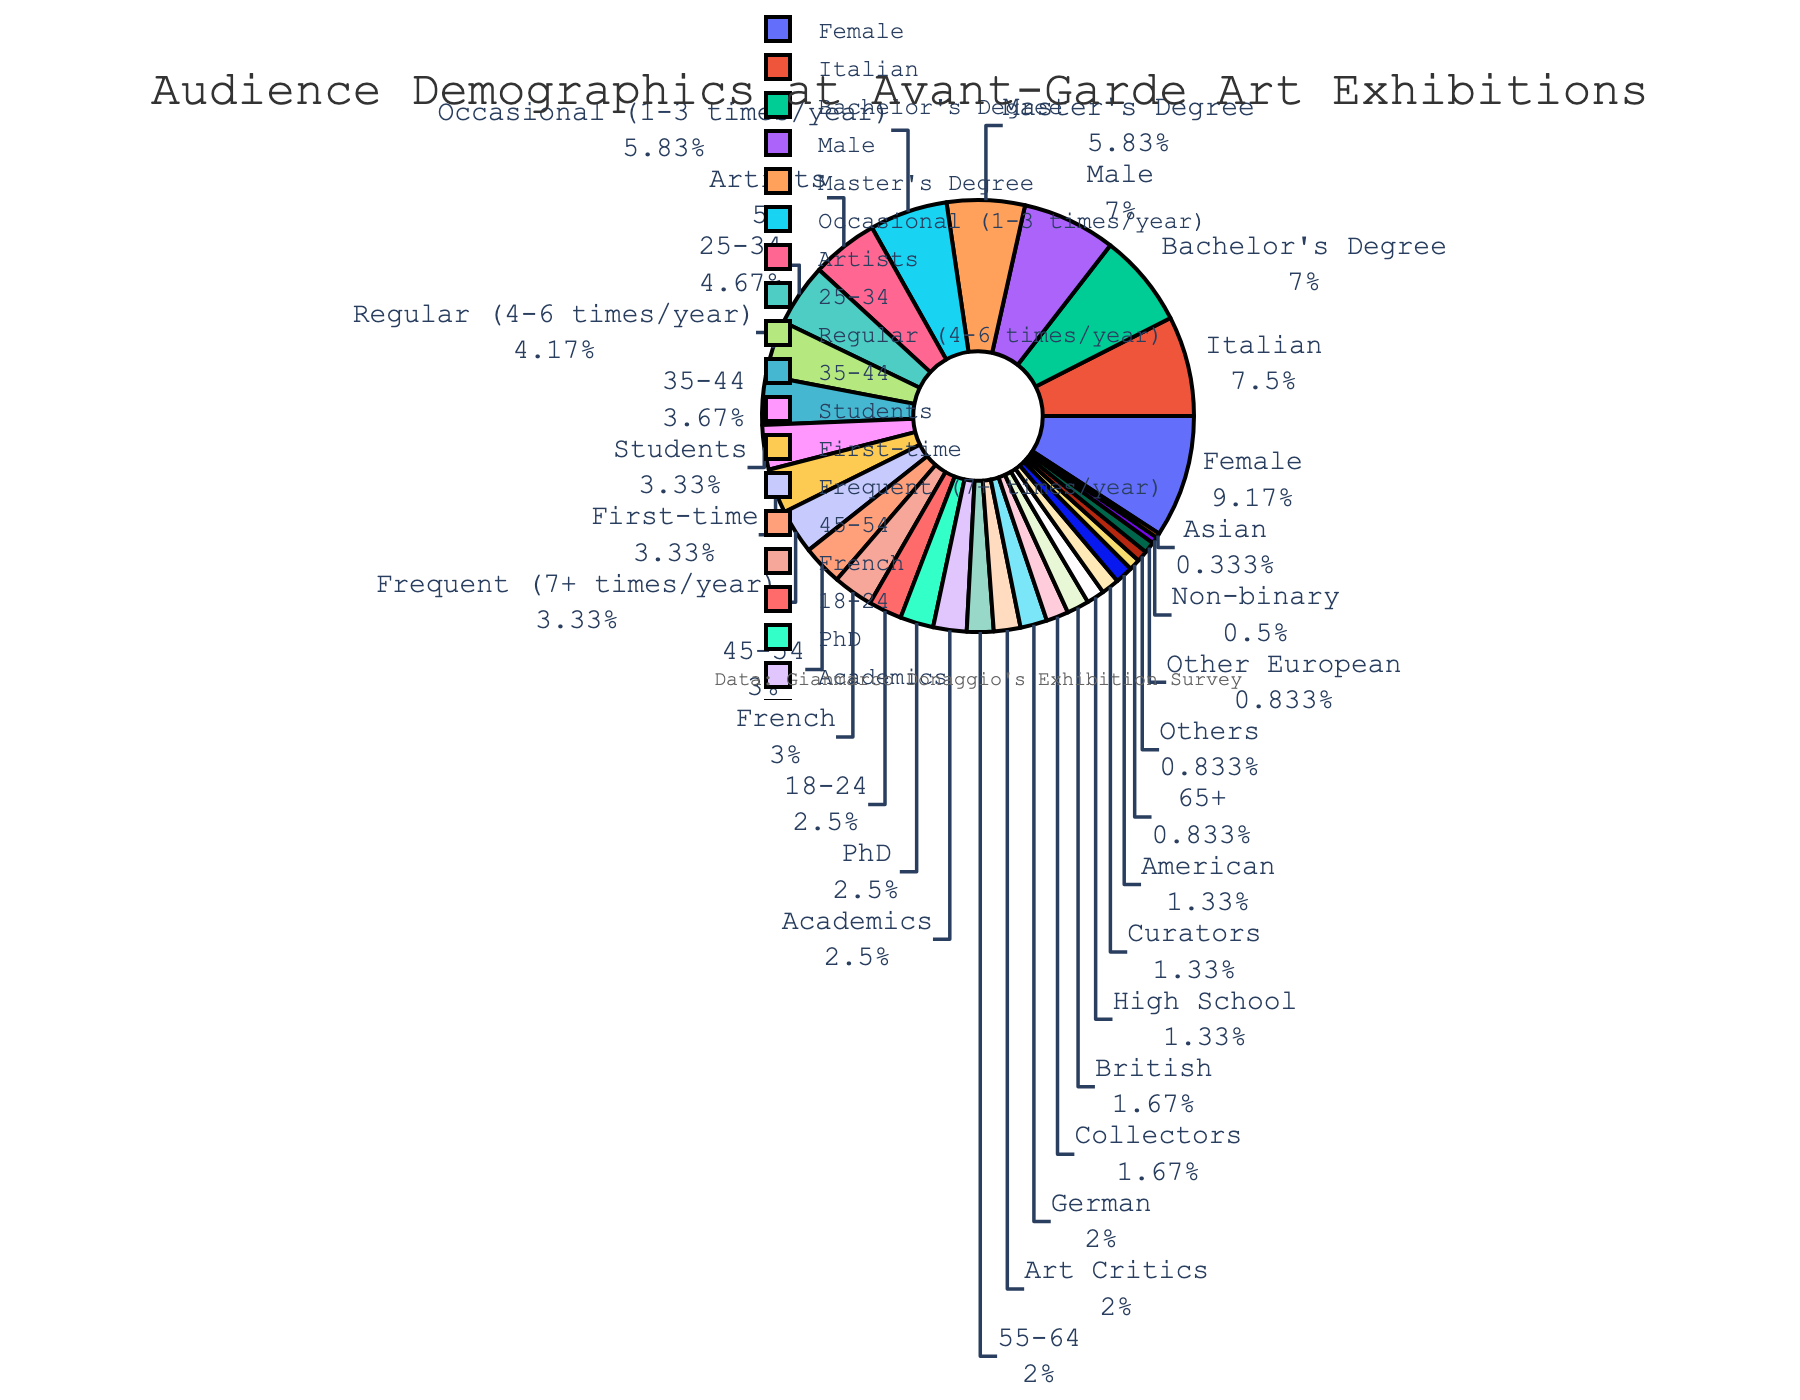What age group has the highest percentage representation? Look at the age groups and compare their percentages. The 25-34 age group has the highest percentage, which is 28%.
Answer: 25-34 Which two age groups combined make up exactly 40% of the audience? Add the percentages of different age groups to find the pair that sums to 40%. The age groups 18-24 (15%) and 45-54 (18%) together make up 15% + 18% = 33%, while 25-34 (28%) and 12-54 (12%) sum to 40%.
Answer: 25-34 and 55-64 Out of the age groups, which one has the smallest slice/color in the pie chart? Observe the slices and their corresponding segments. The age group 65+ has the smallest segment, which is 5%.
Answer: 65+ How does the percentage of males compare to the percentage of females? Compare the percentages of male and female attendees. Females constitute 55% and males 42%, indicating females are more represented.
Answer: Females have a higher percentage If you combine the percentages of regular and frequent attendees, what is the total percentage? Add the percentages of regular (25%) and frequent (20%) attendees. Regular + Frequent makes 25% + 20% = 45%.
Answer: 45% Which occupation group has the highest and which has the lowest representation? Compare the different occupation percentages. Artists are the most represented at 30%, and "Others" is the least represented at 5%.
Answer: Highest: Artists, Lowest: Others Which education level represents more than one-third of the audience? Identify the education level with more than 33%. Bachelor's Degree represents 42% of the audience, which is more than one-third.
Answer: Bachelor's Degree What is the sum of the percentages of the German, British, and American nationalities? Add up the percentages of the German (12%), British (10%), and American (8%) attendees. 12% + 10% + 8% = 30%.
Answer: 30% What color is used to represent the 18-24 age group? Observe the color assigned to the 18-24 age group in the pie chart. It is represented by the first color in the color palette, which is a shade of red.
Answer: Red How many different gender categories are depicted in the pie chart? Count the different gender categories shown. The chart includes Female, Male, and Non-binary, totaling 3 categories.
Answer: 3 